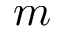Convert formula to latex. <formula><loc_0><loc_0><loc_500><loc_500>m</formula> 